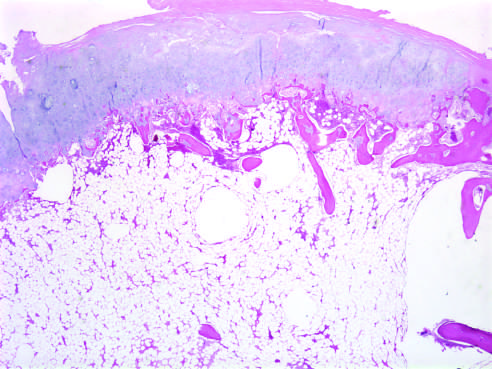does the cartilage cap have the histologic appearance of disorganized growth plate-like cartilage?
Answer the question using a single word or phrase. Yes 